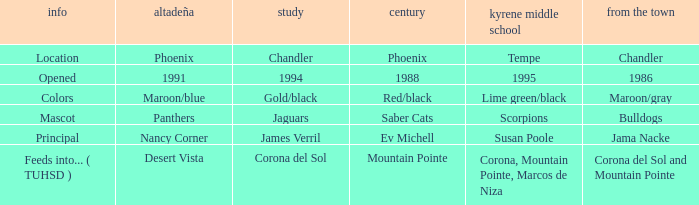Which Centennial has a del Pueblo of 1986? 1988.0. Write the full table. {'header': ['info', 'altadeña', 'study', 'century', 'kyrene middle school', 'from the town'], 'rows': [['Location', 'Phoenix', 'Chandler', 'Phoenix', 'Tempe', 'Chandler'], ['Opened', '1991', '1994', '1988', '1995', '1986'], ['Colors', 'Maroon/blue', 'Gold/black', 'Red/black', 'Lime green/black', 'Maroon/gray'], ['Mascot', 'Panthers', 'Jaguars', 'Saber Cats', 'Scorpions', 'Bulldogs'], ['Principal', 'Nancy Corner', 'James Verril', 'Ev Michell', 'Susan Poole', 'Jama Nacke'], ['Feeds into... ( TUHSD )', 'Desert Vista', 'Corona del Sol', 'Mountain Pointe', 'Corona, Mountain Pointe, Marcos de Niza', 'Corona del Sol and Mountain Pointe']]} 